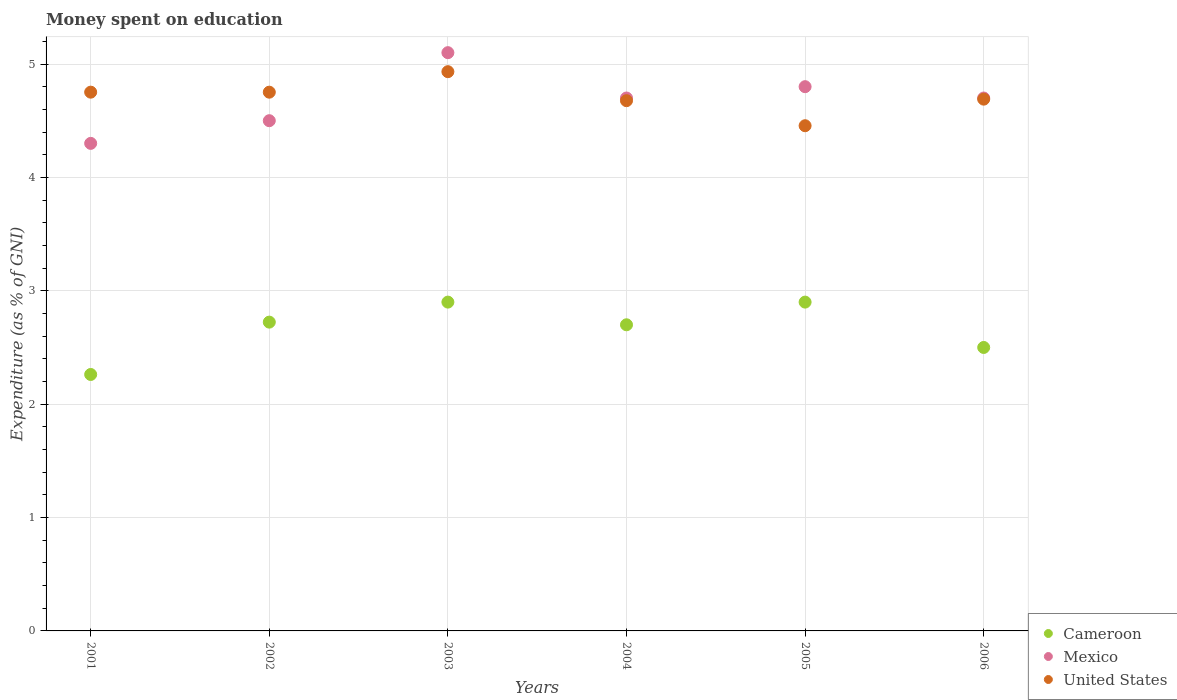How many different coloured dotlines are there?
Keep it short and to the point. 3. Is the number of dotlines equal to the number of legend labels?
Your response must be concise. Yes. What is the amount of money spent on education in Cameroon in 2002?
Keep it short and to the point. 2.72. Across all years, what is the maximum amount of money spent on education in Cameroon?
Offer a very short reply. 2.9. Across all years, what is the minimum amount of money spent on education in United States?
Your response must be concise. 4.46. In which year was the amount of money spent on education in United States maximum?
Offer a very short reply. 2003. What is the total amount of money spent on education in United States in the graph?
Make the answer very short. 28.26. What is the difference between the amount of money spent on education in United States in 2003 and that in 2004?
Offer a very short reply. 0.26. What is the difference between the amount of money spent on education in Mexico in 2004 and the amount of money spent on education in United States in 2002?
Offer a terse response. -0.05. What is the average amount of money spent on education in United States per year?
Provide a short and direct response. 4.71. In the year 2001, what is the difference between the amount of money spent on education in Mexico and amount of money spent on education in Cameroon?
Offer a terse response. 2.04. In how many years, is the amount of money spent on education in United States greater than 1.4 %?
Give a very brief answer. 6. What is the ratio of the amount of money spent on education in Cameroon in 2002 to that in 2006?
Keep it short and to the point. 1.09. Is the amount of money spent on education in United States in 2001 less than that in 2005?
Ensure brevity in your answer.  No. What is the difference between the highest and the second highest amount of money spent on education in Mexico?
Provide a short and direct response. 0.3. What is the difference between the highest and the lowest amount of money spent on education in Mexico?
Offer a very short reply. 0.8. In how many years, is the amount of money spent on education in United States greater than the average amount of money spent on education in United States taken over all years?
Your answer should be very brief. 3. How many dotlines are there?
Give a very brief answer. 3. How many years are there in the graph?
Make the answer very short. 6. What is the difference between two consecutive major ticks on the Y-axis?
Provide a short and direct response. 1. Where does the legend appear in the graph?
Give a very brief answer. Bottom right. How many legend labels are there?
Your response must be concise. 3. What is the title of the graph?
Make the answer very short. Money spent on education. What is the label or title of the Y-axis?
Your answer should be compact. Expenditure (as % of GNI). What is the Expenditure (as % of GNI) in Cameroon in 2001?
Your response must be concise. 2.26. What is the Expenditure (as % of GNI) of Mexico in 2001?
Your answer should be compact. 4.3. What is the Expenditure (as % of GNI) in United States in 2001?
Your answer should be compact. 4.75. What is the Expenditure (as % of GNI) in Cameroon in 2002?
Make the answer very short. 2.72. What is the Expenditure (as % of GNI) in Mexico in 2002?
Provide a short and direct response. 4.5. What is the Expenditure (as % of GNI) in United States in 2002?
Keep it short and to the point. 4.75. What is the Expenditure (as % of GNI) in Cameroon in 2003?
Your response must be concise. 2.9. What is the Expenditure (as % of GNI) of Mexico in 2003?
Ensure brevity in your answer.  5.1. What is the Expenditure (as % of GNI) in United States in 2003?
Provide a succinct answer. 4.93. What is the Expenditure (as % of GNI) in Cameroon in 2004?
Your answer should be very brief. 2.7. What is the Expenditure (as % of GNI) in United States in 2004?
Provide a short and direct response. 4.68. What is the Expenditure (as % of GNI) in United States in 2005?
Offer a very short reply. 4.46. What is the Expenditure (as % of GNI) in United States in 2006?
Provide a succinct answer. 4.69. Across all years, what is the maximum Expenditure (as % of GNI) in Mexico?
Provide a succinct answer. 5.1. Across all years, what is the maximum Expenditure (as % of GNI) of United States?
Ensure brevity in your answer.  4.93. Across all years, what is the minimum Expenditure (as % of GNI) of Cameroon?
Offer a very short reply. 2.26. Across all years, what is the minimum Expenditure (as % of GNI) in Mexico?
Offer a very short reply. 4.3. Across all years, what is the minimum Expenditure (as % of GNI) in United States?
Ensure brevity in your answer.  4.46. What is the total Expenditure (as % of GNI) of Cameroon in the graph?
Give a very brief answer. 15.99. What is the total Expenditure (as % of GNI) in Mexico in the graph?
Give a very brief answer. 28.1. What is the total Expenditure (as % of GNI) in United States in the graph?
Provide a short and direct response. 28.26. What is the difference between the Expenditure (as % of GNI) of Cameroon in 2001 and that in 2002?
Offer a terse response. -0.46. What is the difference between the Expenditure (as % of GNI) of United States in 2001 and that in 2002?
Keep it short and to the point. 0. What is the difference between the Expenditure (as % of GNI) in Cameroon in 2001 and that in 2003?
Offer a terse response. -0.64. What is the difference between the Expenditure (as % of GNI) in Mexico in 2001 and that in 2003?
Make the answer very short. -0.8. What is the difference between the Expenditure (as % of GNI) in United States in 2001 and that in 2003?
Keep it short and to the point. -0.18. What is the difference between the Expenditure (as % of GNI) in Cameroon in 2001 and that in 2004?
Keep it short and to the point. -0.44. What is the difference between the Expenditure (as % of GNI) in Mexico in 2001 and that in 2004?
Make the answer very short. -0.4. What is the difference between the Expenditure (as % of GNI) in United States in 2001 and that in 2004?
Provide a succinct answer. 0.08. What is the difference between the Expenditure (as % of GNI) of Cameroon in 2001 and that in 2005?
Provide a succinct answer. -0.64. What is the difference between the Expenditure (as % of GNI) in Mexico in 2001 and that in 2005?
Provide a short and direct response. -0.5. What is the difference between the Expenditure (as % of GNI) of United States in 2001 and that in 2005?
Your response must be concise. 0.3. What is the difference between the Expenditure (as % of GNI) of Cameroon in 2001 and that in 2006?
Offer a very short reply. -0.24. What is the difference between the Expenditure (as % of GNI) in Mexico in 2001 and that in 2006?
Your answer should be very brief. -0.4. What is the difference between the Expenditure (as % of GNI) in United States in 2001 and that in 2006?
Offer a terse response. 0.06. What is the difference between the Expenditure (as % of GNI) of Cameroon in 2002 and that in 2003?
Offer a very short reply. -0.18. What is the difference between the Expenditure (as % of GNI) in United States in 2002 and that in 2003?
Your answer should be very brief. -0.18. What is the difference between the Expenditure (as % of GNI) in Cameroon in 2002 and that in 2004?
Ensure brevity in your answer.  0.02. What is the difference between the Expenditure (as % of GNI) of United States in 2002 and that in 2004?
Keep it short and to the point. 0.07. What is the difference between the Expenditure (as % of GNI) in Cameroon in 2002 and that in 2005?
Provide a short and direct response. -0.18. What is the difference between the Expenditure (as % of GNI) of Mexico in 2002 and that in 2005?
Give a very brief answer. -0.3. What is the difference between the Expenditure (as % of GNI) in United States in 2002 and that in 2005?
Your response must be concise. 0.3. What is the difference between the Expenditure (as % of GNI) in Cameroon in 2002 and that in 2006?
Provide a short and direct response. 0.22. What is the difference between the Expenditure (as % of GNI) of Mexico in 2002 and that in 2006?
Give a very brief answer. -0.2. What is the difference between the Expenditure (as % of GNI) of United States in 2002 and that in 2006?
Ensure brevity in your answer.  0.06. What is the difference between the Expenditure (as % of GNI) of Cameroon in 2003 and that in 2004?
Ensure brevity in your answer.  0.2. What is the difference between the Expenditure (as % of GNI) in Mexico in 2003 and that in 2004?
Your answer should be compact. 0.4. What is the difference between the Expenditure (as % of GNI) in United States in 2003 and that in 2004?
Your response must be concise. 0.26. What is the difference between the Expenditure (as % of GNI) of United States in 2003 and that in 2005?
Your response must be concise. 0.48. What is the difference between the Expenditure (as % of GNI) of United States in 2003 and that in 2006?
Provide a succinct answer. 0.24. What is the difference between the Expenditure (as % of GNI) of United States in 2004 and that in 2005?
Your response must be concise. 0.22. What is the difference between the Expenditure (as % of GNI) of Cameroon in 2004 and that in 2006?
Offer a very short reply. 0.2. What is the difference between the Expenditure (as % of GNI) in Mexico in 2004 and that in 2006?
Provide a succinct answer. 0. What is the difference between the Expenditure (as % of GNI) of United States in 2004 and that in 2006?
Offer a very short reply. -0.01. What is the difference between the Expenditure (as % of GNI) in Cameroon in 2005 and that in 2006?
Make the answer very short. 0.4. What is the difference between the Expenditure (as % of GNI) in Mexico in 2005 and that in 2006?
Offer a very short reply. 0.1. What is the difference between the Expenditure (as % of GNI) of United States in 2005 and that in 2006?
Keep it short and to the point. -0.23. What is the difference between the Expenditure (as % of GNI) of Cameroon in 2001 and the Expenditure (as % of GNI) of Mexico in 2002?
Make the answer very short. -2.24. What is the difference between the Expenditure (as % of GNI) in Cameroon in 2001 and the Expenditure (as % of GNI) in United States in 2002?
Offer a terse response. -2.49. What is the difference between the Expenditure (as % of GNI) in Mexico in 2001 and the Expenditure (as % of GNI) in United States in 2002?
Keep it short and to the point. -0.45. What is the difference between the Expenditure (as % of GNI) of Cameroon in 2001 and the Expenditure (as % of GNI) of Mexico in 2003?
Your answer should be very brief. -2.84. What is the difference between the Expenditure (as % of GNI) of Cameroon in 2001 and the Expenditure (as % of GNI) of United States in 2003?
Provide a short and direct response. -2.67. What is the difference between the Expenditure (as % of GNI) in Mexico in 2001 and the Expenditure (as % of GNI) in United States in 2003?
Keep it short and to the point. -0.63. What is the difference between the Expenditure (as % of GNI) in Cameroon in 2001 and the Expenditure (as % of GNI) in Mexico in 2004?
Your answer should be very brief. -2.44. What is the difference between the Expenditure (as % of GNI) of Cameroon in 2001 and the Expenditure (as % of GNI) of United States in 2004?
Offer a very short reply. -2.41. What is the difference between the Expenditure (as % of GNI) of Mexico in 2001 and the Expenditure (as % of GNI) of United States in 2004?
Your answer should be very brief. -0.38. What is the difference between the Expenditure (as % of GNI) in Cameroon in 2001 and the Expenditure (as % of GNI) in Mexico in 2005?
Provide a succinct answer. -2.54. What is the difference between the Expenditure (as % of GNI) in Cameroon in 2001 and the Expenditure (as % of GNI) in United States in 2005?
Ensure brevity in your answer.  -2.19. What is the difference between the Expenditure (as % of GNI) of Mexico in 2001 and the Expenditure (as % of GNI) of United States in 2005?
Your answer should be compact. -0.16. What is the difference between the Expenditure (as % of GNI) of Cameroon in 2001 and the Expenditure (as % of GNI) of Mexico in 2006?
Ensure brevity in your answer.  -2.44. What is the difference between the Expenditure (as % of GNI) of Cameroon in 2001 and the Expenditure (as % of GNI) of United States in 2006?
Provide a succinct answer. -2.43. What is the difference between the Expenditure (as % of GNI) in Mexico in 2001 and the Expenditure (as % of GNI) in United States in 2006?
Give a very brief answer. -0.39. What is the difference between the Expenditure (as % of GNI) in Cameroon in 2002 and the Expenditure (as % of GNI) in Mexico in 2003?
Offer a terse response. -2.38. What is the difference between the Expenditure (as % of GNI) of Cameroon in 2002 and the Expenditure (as % of GNI) of United States in 2003?
Ensure brevity in your answer.  -2.21. What is the difference between the Expenditure (as % of GNI) of Mexico in 2002 and the Expenditure (as % of GNI) of United States in 2003?
Offer a terse response. -0.43. What is the difference between the Expenditure (as % of GNI) of Cameroon in 2002 and the Expenditure (as % of GNI) of Mexico in 2004?
Offer a terse response. -1.98. What is the difference between the Expenditure (as % of GNI) in Cameroon in 2002 and the Expenditure (as % of GNI) in United States in 2004?
Your answer should be very brief. -1.95. What is the difference between the Expenditure (as % of GNI) in Mexico in 2002 and the Expenditure (as % of GNI) in United States in 2004?
Your response must be concise. -0.18. What is the difference between the Expenditure (as % of GNI) in Cameroon in 2002 and the Expenditure (as % of GNI) in Mexico in 2005?
Make the answer very short. -2.08. What is the difference between the Expenditure (as % of GNI) in Cameroon in 2002 and the Expenditure (as % of GNI) in United States in 2005?
Offer a terse response. -1.73. What is the difference between the Expenditure (as % of GNI) of Mexico in 2002 and the Expenditure (as % of GNI) of United States in 2005?
Your response must be concise. 0.04. What is the difference between the Expenditure (as % of GNI) in Cameroon in 2002 and the Expenditure (as % of GNI) in Mexico in 2006?
Offer a very short reply. -1.98. What is the difference between the Expenditure (as % of GNI) of Cameroon in 2002 and the Expenditure (as % of GNI) of United States in 2006?
Keep it short and to the point. -1.97. What is the difference between the Expenditure (as % of GNI) in Mexico in 2002 and the Expenditure (as % of GNI) in United States in 2006?
Your answer should be compact. -0.19. What is the difference between the Expenditure (as % of GNI) of Cameroon in 2003 and the Expenditure (as % of GNI) of Mexico in 2004?
Your answer should be very brief. -1.8. What is the difference between the Expenditure (as % of GNI) of Cameroon in 2003 and the Expenditure (as % of GNI) of United States in 2004?
Offer a terse response. -1.78. What is the difference between the Expenditure (as % of GNI) of Mexico in 2003 and the Expenditure (as % of GNI) of United States in 2004?
Your response must be concise. 0.42. What is the difference between the Expenditure (as % of GNI) of Cameroon in 2003 and the Expenditure (as % of GNI) of United States in 2005?
Your response must be concise. -1.56. What is the difference between the Expenditure (as % of GNI) in Mexico in 2003 and the Expenditure (as % of GNI) in United States in 2005?
Your answer should be very brief. 0.64. What is the difference between the Expenditure (as % of GNI) of Cameroon in 2003 and the Expenditure (as % of GNI) of United States in 2006?
Keep it short and to the point. -1.79. What is the difference between the Expenditure (as % of GNI) in Mexico in 2003 and the Expenditure (as % of GNI) in United States in 2006?
Make the answer very short. 0.41. What is the difference between the Expenditure (as % of GNI) in Cameroon in 2004 and the Expenditure (as % of GNI) in United States in 2005?
Your answer should be very brief. -1.76. What is the difference between the Expenditure (as % of GNI) of Mexico in 2004 and the Expenditure (as % of GNI) of United States in 2005?
Your response must be concise. 0.24. What is the difference between the Expenditure (as % of GNI) in Cameroon in 2004 and the Expenditure (as % of GNI) in United States in 2006?
Offer a very short reply. -1.99. What is the difference between the Expenditure (as % of GNI) of Mexico in 2004 and the Expenditure (as % of GNI) of United States in 2006?
Keep it short and to the point. 0.01. What is the difference between the Expenditure (as % of GNI) in Cameroon in 2005 and the Expenditure (as % of GNI) in United States in 2006?
Make the answer very short. -1.79. What is the difference between the Expenditure (as % of GNI) in Mexico in 2005 and the Expenditure (as % of GNI) in United States in 2006?
Give a very brief answer. 0.11. What is the average Expenditure (as % of GNI) in Cameroon per year?
Offer a terse response. 2.66. What is the average Expenditure (as % of GNI) of Mexico per year?
Your answer should be compact. 4.68. What is the average Expenditure (as % of GNI) in United States per year?
Keep it short and to the point. 4.71. In the year 2001, what is the difference between the Expenditure (as % of GNI) in Cameroon and Expenditure (as % of GNI) in Mexico?
Keep it short and to the point. -2.04. In the year 2001, what is the difference between the Expenditure (as % of GNI) of Cameroon and Expenditure (as % of GNI) of United States?
Offer a very short reply. -2.49. In the year 2001, what is the difference between the Expenditure (as % of GNI) in Mexico and Expenditure (as % of GNI) in United States?
Provide a succinct answer. -0.45. In the year 2002, what is the difference between the Expenditure (as % of GNI) of Cameroon and Expenditure (as % of GNI) of Mexico?
Provide a short and direct response. -1.78. In the year 2002, what is the difference between the Expenditure (as % of GNI) of Cameroon and Expenditure (as % of GNI) of United States?
Make the answer very short. -2.03. In the year 2002, what is the difference between the Expenditure (as % of GNI) of Mexico and Expenditure (as % of GNI) of United States?
Your answer should be very brief. -0.25. In the year 2003, what is the difference between the Expenditure (as % of GNI) of Cameroon and Expenditure (as % of GNI) of Mexico?
Keep it short and to the point. -2.2. In the year 2003, what is the difference between the Expenditure (as % of GNI) of Cameroon and Expenditure (as % of GNI) of United States?
Your answer should be very brief. -2.03. In the year 2003, what is the difference between the Expenditure (as % of GNI) in Mexico and Expenditure (as % of GNI) in United States?
Provide a succinct answer. 0.17. In the year 2004, what is the difference between the Expenditure (as % of GNI) of Cameroon and Expenditure (as % of GNI) of United States?
Keep it short and to the point. -1.98. In the year 2004, what is the difference between the Expenditure (as % of GNI) of Mexico and Expenditure (as % of GNI) of United States?
Offer a terse response. 0.02. In the year 2005, what is the difference between the Expenditure (as % of GNI) of Cameroon and Expenditure (as % of GNI) of United States?
Provide a short and direct response. -1.56. In the year 2005, what is the difference between the Expenditure (as % of GNI) in Mexico and Expenditure (as % of GNI) in United States?
Provide a succinct answer. 0.34. In the year 2006, what is the difference between the Expenditure (as % of GNI) in Cameroon and Expenditure (as % of GNI) in Mexico?
Keep it short and to the point. -2.2. In the year 2006, what is the difference between the Expenditure (as % of GNI) in Cameroon and Expenditure (as % of GNI) in United States?
Ensure brevity in your answer.  -2.19. In the year 2006, what is the difference between the Expenditure (as % of GNI) of Mexico and Expenditure (as % of GNI) of United States?
Ensure brevity in your answer.  0.01. What is the ratio of the Expenditure (as % of GNI) in Cameroon in 2001 to that in 2002?
Your answer should be very brief. 0.83. What is the ratio of the Expenditure (as % of GNI) of Mexico in 2001 to that in 2002?
Offer a very short reply. 0.96. What is the ratio of the Expenditure (as % of GNI) of Cameroon in 2001 to that in 2003?
Provide a short and direct response. 0.78. What is the ratio of the Expenditure (as % of GNI) of Mexico in 2001 to that in 2003?
Provide a short and direct response. 0.84. What is the ratio of the Expenditure (as % of GNI) in United States in 2001 to that in 2003?
Offer a terse response. 0.96. What is the ratio of the Expenditure (as % of GNI) in Cameroon in 2001 to that in 2004?
Your response must be concise. 0.84. What is the ratio of the Expenditure (as % of GNI) in Mexico in 2001 to that in 2004?
Give a very brief answer. 0.91. What is the ratio of the Expenditure (as % of GNI) of United States in 2001 to that in 2004?
Give a very brief answer. 1.02. What is the ratio of the Expenditure (as % of GNI) in Cameroon in 2001 to that in 2005?
Keep it short and to the point. 0.78. What is the ratio of the Expenditure (as % of GNI) of Mexico in 2001 to that in 2005?
Keep it short and to the point. 0.9. What is the ratio of the Expenditure (as % of GNI) of United States in 2001 to that in 2005?
Provide a short and direct response. 1.07. What is the ratio of the Expenditure (as % of GNI) of Cameroon in 2001 to that in 2006?
Offer a terse response. 0.9. What is the ratio of the Expenditure (as % of GNI) in Mexico in 2001 to that in 2006?
Provide a short and direct response. 0.91. What is the ratio of the Expenditure (as % of GNI) of United States in 2001 to that in 2006?
Keep it short and to the point. 1.01. What is the ratio of the Expenditure (as % of GNI) of Cameroon in 2002 to that in 2003?
Provide a succinct answer. 0.94. What is the ratio of the Expenditure (as % of GNI) in Mexico in 2002 to that in 2003?
Give a very brief answer. 0.88. What is the ratio of the Expenditure (as % of GNI) of United States in 2002 to that in 2003?
Your answer should be very brief. 0.96. What is the ratio of the Expenditure (as % of GNI) in Cameroon in 2002 to that in 2004?
Provide a succinct answer. 1.01. What is the ratio of the Expenditure (as % of GNI) of Mexico in 2002 to that in 2004?
Your answer should be compact. 0.96. What is the ratio of the Expenditure (as % of GNI) in United States in 2002 to that in 2004?
Your answer should be compact. 1.02. What is the ratio of the Expenditure (as % of GNI) in Cameroon in 2002 to that in 2005?
Offer a very short reply. 0.94. What is the ratio of the Expenditure (as % of GNI) of United States in 2002 to that in 2005?
Your answer should be compact. 1.07. What is the ratio of the Expenditure (as % of GNI) of Cameroon in 2002 to that in 2006?
Keep it short and to the point. 1.09. What is the ratio of the Expenditure (as % of GNI) of Mexico in 2002 to that in 2006?
Give a very brief answer. 0.96. What is the ratio of the Expenditure (as % of GNI) of United States in 2002 to that in 2006?
Offer a terse response. 1.01. What is the ratio of the Expenditure (as % of GNI) in Cameroon in 2003 to that in 2004?
Make the answer very short. 1.07. What is the ratio of the Expenditure (as % of GNI) of Mexico in 2003 to that in 2004?
Your response must be concise. 1.09. What is the ratio of the Expenditure (as % of GNI) in United States in 2003 to that in 2004?
Provide a short and direct response. 1.05. What is the ratio of the Expenditure (as % of GNI) of Mexico in 2003 to that in 2005?
Give a very brief answer. 1.06. What is the ratio of the Expenditure (as % of GNI) of United States in 2003 to that in 2005?
Your answer should be compact. 1.11. What is the ratio of the Expenditure (as % of GNI) in Cameroon in 2003 to that in 2006?
Your answer should be very brief. 1.16. What is the ratio of the Expenditure (as % of GNI) of Mexico in 2003 to that in 2006?
Keep it short and to the point. 1.09. What is the ratio of the Expenditure (as % of GNI) in United States in 2003 to that in 2006?
Your answer should be very brief. 1.05. What is the ratio of the Expenditure (as % of GNI) of Mexico in 2004 to that in 2005?
Your answer should be compact. 0.98. What is the ratio of the Expenditure (as % of GNI) of United States in 2004 to that in 2005?
Make the answer very short. 1.05. What is the ratio of the Expenditure (as % of GNI) in Cameroon in 2005 to that in 2006?
Give a very brief answer. 1.16. What is the ratio of the Expenditure (as % of GNI) of Mexico in 2005 to that in 2006?
Ensure brevity in your answer.  1.02. What is the ratio of the Expenditure (as % of GNI) in United States in 2005 to that in 2006?
Your answer should be very brief. 0.95. What is the difference between the highest and the second highest Expenditure (as % of GNI) in Cameroon?
Offer a terse response. 0. What is the difference between the highest and the second highest Expenditure (as % of GNI) in Mexico?
Provide a succinct answer. 0.3. What is the difference between the highest and the second highest Expenditure (as % of GNI) of United States?
Make the answer very short. 0.18. What is the difference between the highest and the lowest Expenditure (as % of GNI) in Cameroon?
Make the answer very short. 0.64. What is the difference between the highest and the lowest Expenditure (as % of GNI) of United States?
Offer a terse response. 0.48. 